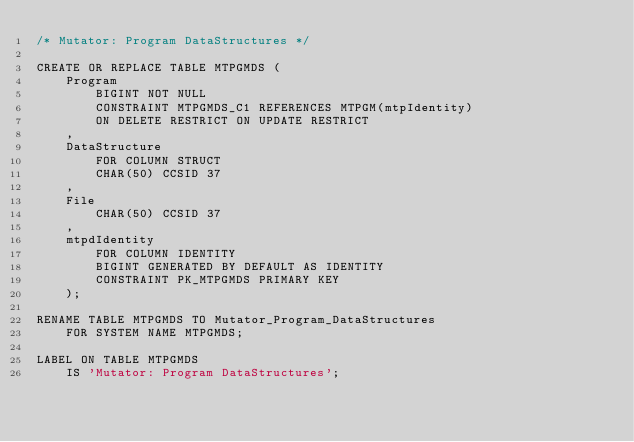Convert code to text. <code><loc_0><loc_0><loc_500><loc_500><_SQL_>/* Mutator: Program DataStructures */

CREATE OR REPLACE TABLE MTPGMDS (                                              
    Program                                                          
        BIGINT NOT NULL                                              
        CONSTRAINT MTPGMDS_C1 REFERENCES MTPGM(mtpIdentity)            
        ON DELETE RESTRICT ON UPDATE RESTRICT                        
    ,                                                                
    DataStructure   
        FOR COLUMN STRUCT
        CHAR(50) CCSID 37                                            
    ,                                                                
    File                                                        
        CHAR(50) CCSID 37                                            
    ,                                                                
    mtpdIdentity                                                         
        FOR COLUMN IDENTITY
        BIGINT GENERATED BY DEFAULT AS IDENTITY                      
        CONSTRAINT PK_MTPGMDS PRIMARY KEY               
    );                                                   
                                                         
RENAME TABLE MTPGMDS TO Mutator_Program_DataStructures
    FOR SYSTEM NAME MTPGMDS;            

LABEL ON TABLE MTPGMDS                                  
    IS 'Mutator: Program DataStructures';                            
                                                         
</code> 